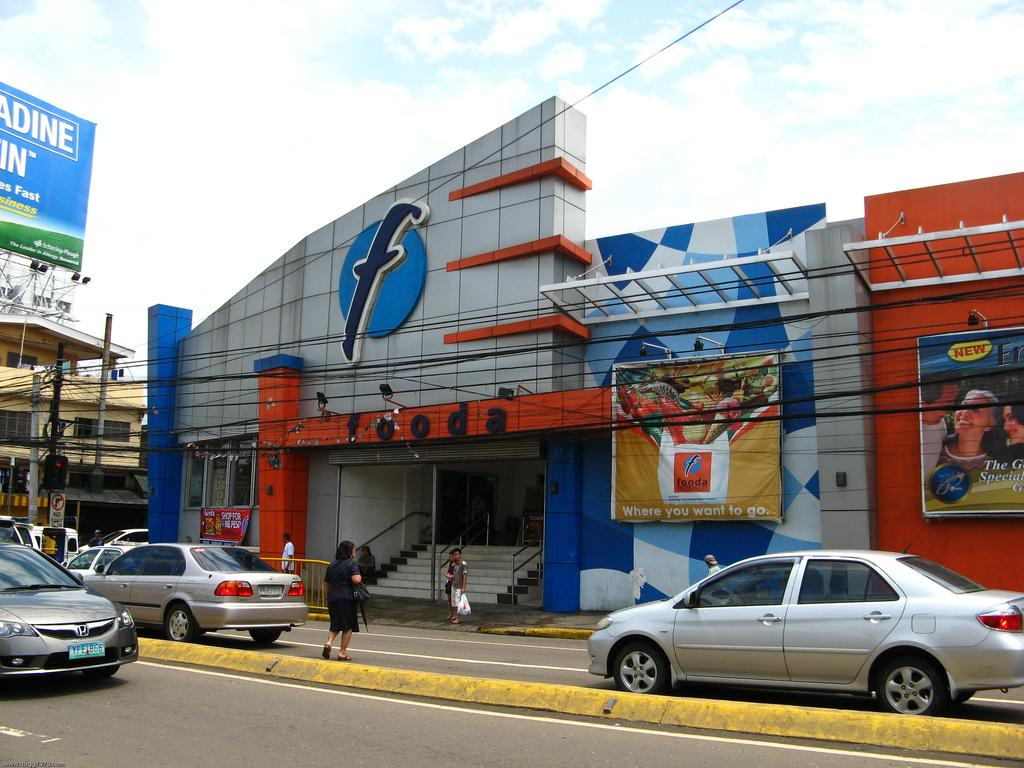<image>
Give a short and clear explanation of the subsequent image. A fooda store front with a sign saying 'where you want to go'. 